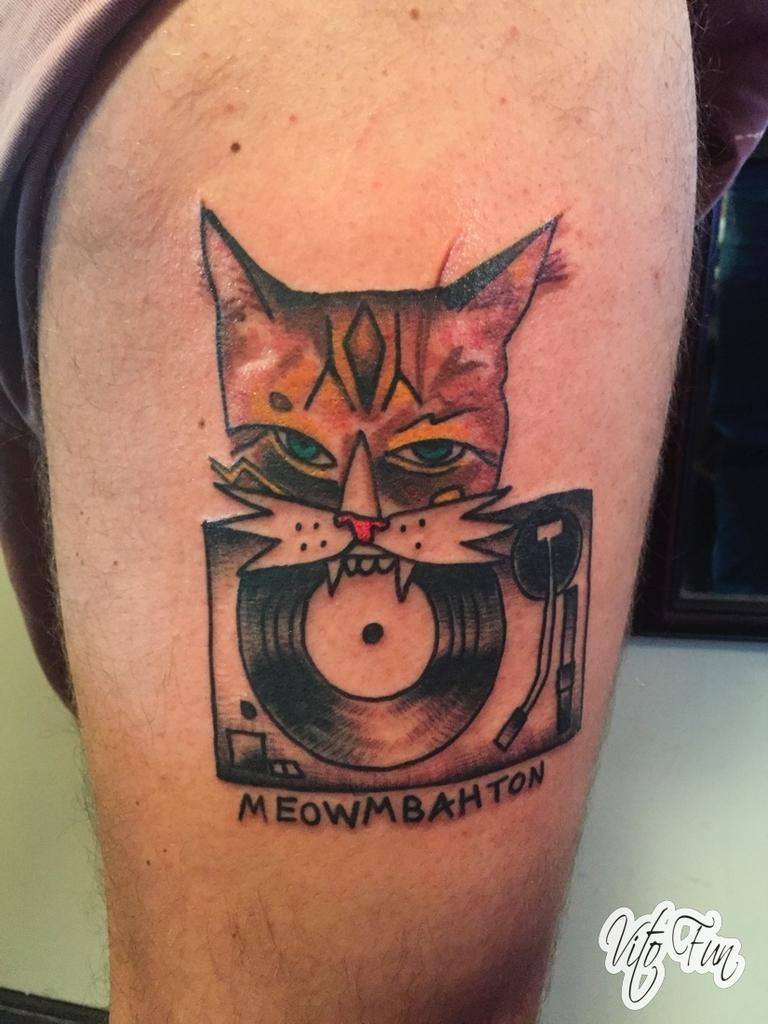What is depicted on the human body in the image? There is a tattoo with text on a human body in the image. Can you describe the text in the tattoo? Unfortunately, the specific text in the tattoo cannot be determined from the image. What else is present in the image besides the tattoo? There is text in the bottom right corner of the image. Can you read the text in the bottom right corner? Unfortunately, the specific text in the bottom right corner cannot be determined from the image. How many clocks are present in the image? There are no clocks visible in the image. What type of authority is depicted in the image? There is no authority figure present in the image. 